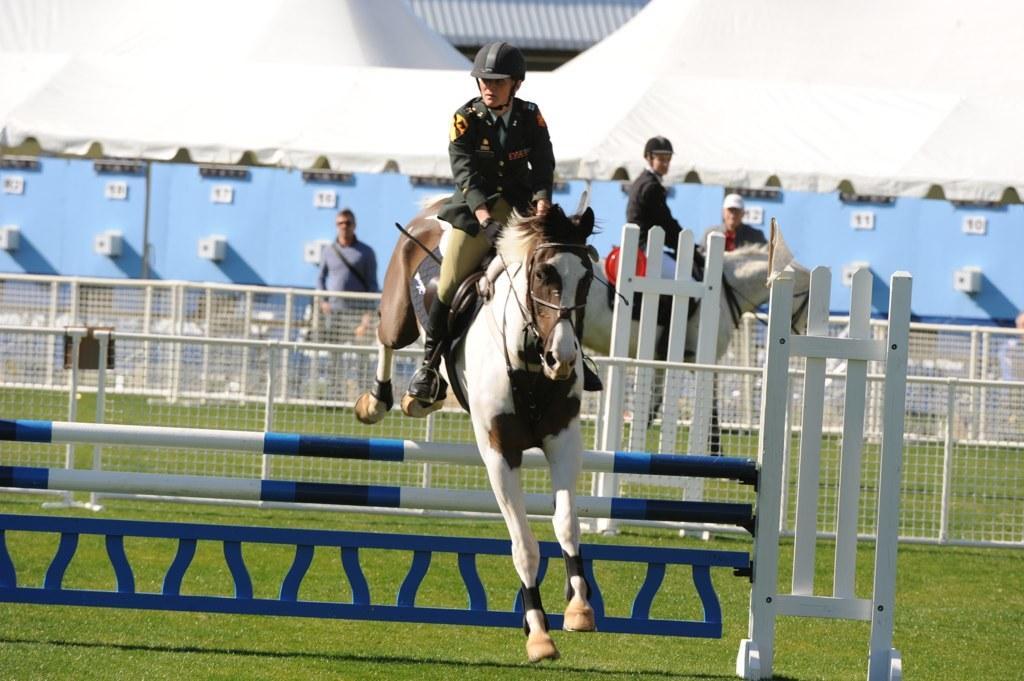Can you describe this image briefly? This image is clicked outside. There are horses in this image. People are sitting on horses. This looks like horse riding. 